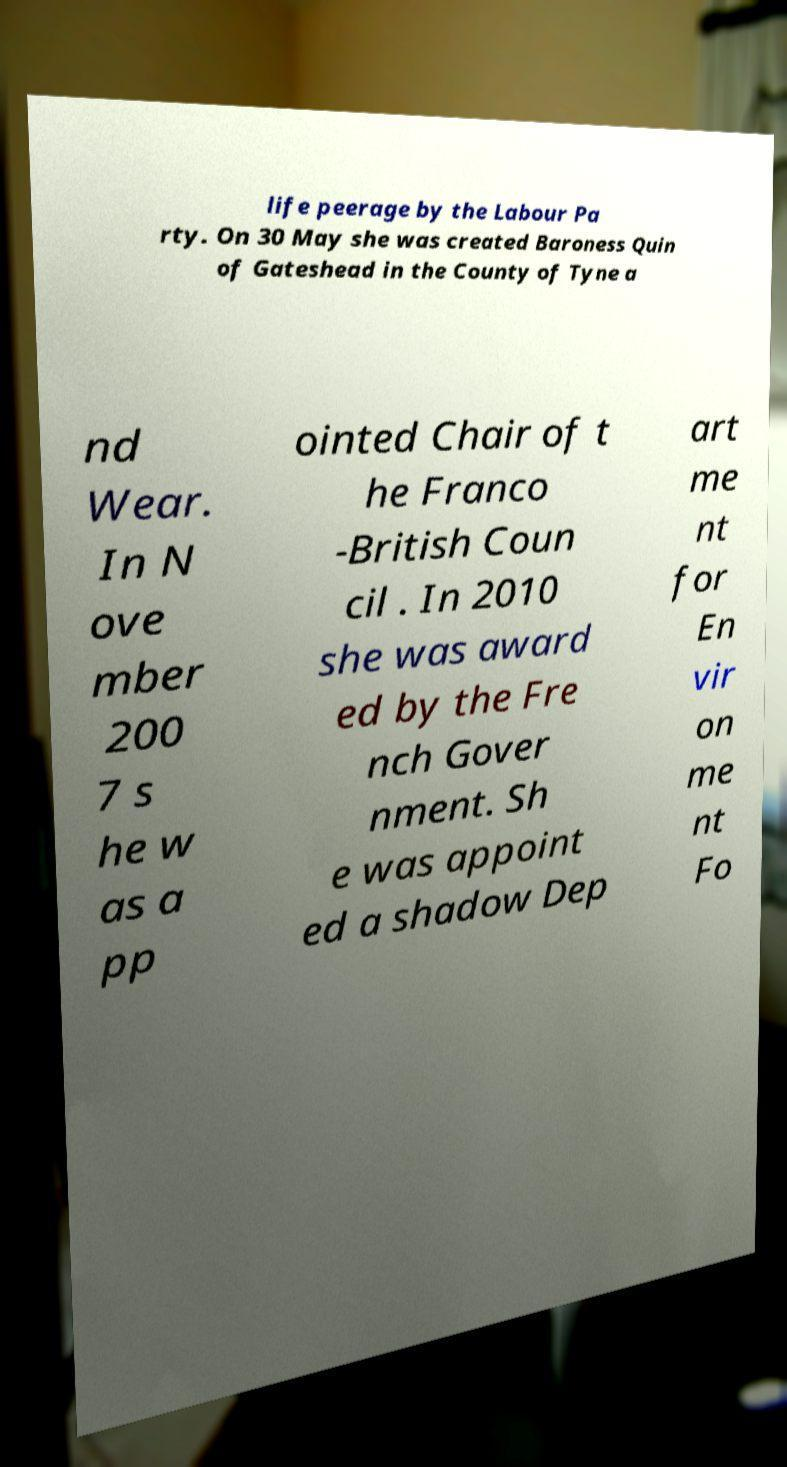What messages or text are displayed in this image? I need them in a readable, typed format. life peerage by the Labour Pa rty. On 30 May she was created Baroness Quin of Gateshead in the County of Tyne a nd Wear. In N ove mber 200 7 s he w as a pp ointed Chair of t he Franco -British Coun cil . In 2010 she was award ed by the Fre nch Gover nment. Sh e was appoint ed a shadow Dep art me nt for En vir on me nt Fo 